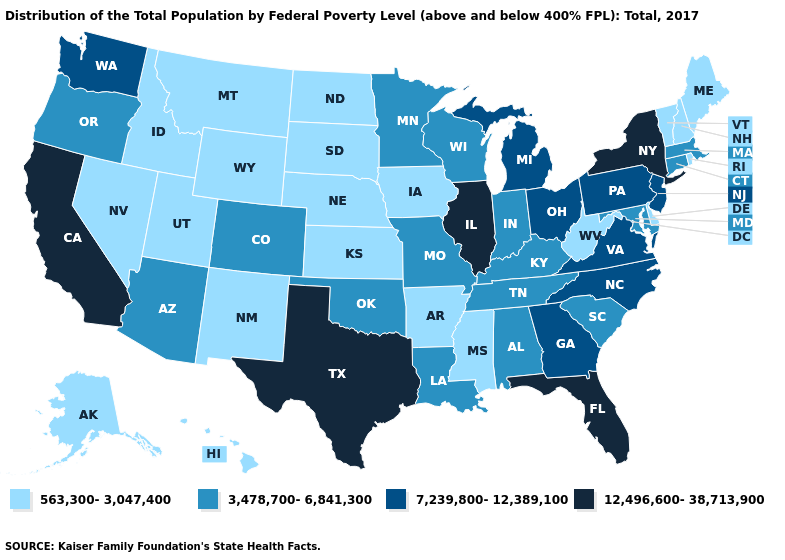What is the highest value in states that border Oregon?
Give a very brief answer. 12,496,600-38,713,900. Which states have the highest value in the USA?
Give a very brief answer. California, Florida, Illinois, New York, Texas. Which states hav the highest value in the West?
Be succinct. California. What is the value of Pennsylvania?
Be succinct. 7,239,800-12,389,100. Does Massachusetts have the lowest value in the USA?
Write a very short answer. No. Does Delaware have the highest value in the South?
Answer briefly. No. Among the states that border Wyoming , does Montana have the highest value?
Answer briefly. No. Name the states that have a value in the range 3,478,700-6,841,300?
Keep it brief. Alabama, Arizona, Colorado, Connecticut, Indiana, Kentucky, Louisiana, Maryland, Massachusetts, Minnesota, Missouri, Oklahoma, Oregon, South Carolina, Tennessee, Wisconsin. Among the states that border Arizona , does California have the highest value?
Be succinct. Yes. Does New York have the highest value in the USA?
Be succinct. Yes. Among the states that border Florida , which have the highest value?
Be succinct. Georgia. Name the states that have a value in the range 7,239,800-12,389,100?
Concise answer only. Georgia, Michigan, New Jersey, North Carolina, Ohio, Pennsylvania, Virginia, Washington. Name the states that have a value in the range 7,239,800-12,389,100?
Write a very short answer. Georgia, Michigan, New Jersey, North Carolina, Ohio, Pennsylvania, Virginia, Washington. What is the highest value in the MidWest ?
Write a very short answer. 12,496,600-38,713,900. Which states have the lowest value in the USA?
Answer briefly. Alaska, Arkansas, Delaware, Hawaii, Idaho, Iowa, Kansas, Maine, Mississippi, Montana, Nebraska, Nevada, New Hampshire, New Mexico, North Dakota, Rhode Island, South Dakota, Utah, Vermont, West Virginia, Wyoming. 